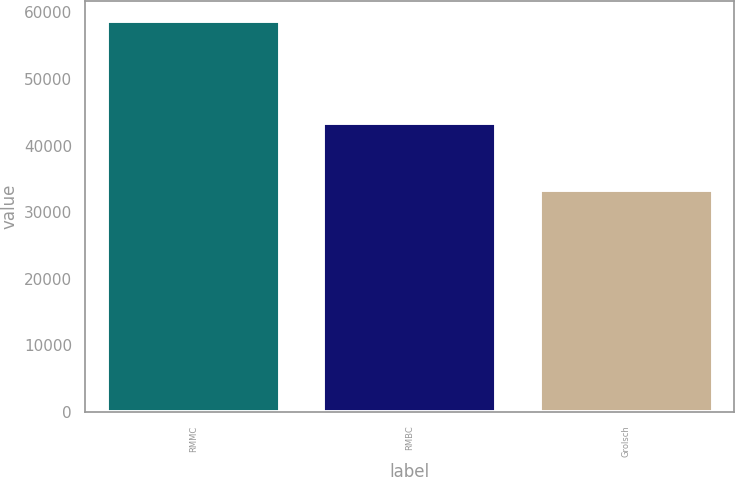Convert chart to OTSL. <chart><loc_0><loc_0><loc_500><loc_500><bar_chart><fcel>RMMC<fcel>RMBC<fcel>Grolsch<nl><fcel>58737<fcel>43441<fcel>33407<nl></chart> 